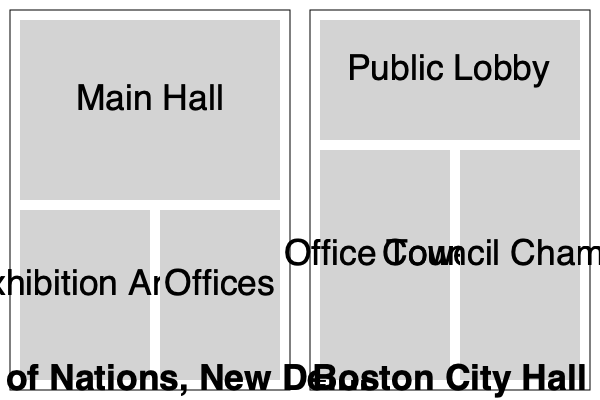Compare and contrast the floor plans of the Hall of Nations in New Delhi and Boston City Hall, focusing on how their spatial arrangements reflect Brutalist principles and their respective functions. How do these designs embody the cultural and political contexts of their locations? To answer this question, we need to analyze the floor plans of both structures step-by-step:

1. Hall of Nations, New Delhi:
   a) Large central space (Main Hall) occupying about half the building's area.
   b) Two smaller spaces below: Exhibition Area and Offices.
   c) Simple, geometric layout with clear divisions.

2. Boston City Hall:
   a) Large Public Lobby at the top.
   b) Two vertical sections below: Office Tower and Council Chamber.
   c) More complex spatial arrangement compared to Hall of Nations.

3. Brutalist principles reflected in both:
   a) Emphasis on raw, exposed structures evident in the simple, geometric forms.
   b) Functionality prioritized over ornamentation.
   c) Clear separation of spaces based on their purposes.

4. Functional aspects:
   a) Hall of Nations: Designed for exhibitions and events, with a large central space and dedicated exhibition area.
   b) Boston City Hall: Designed for governmental functions, with public access areas and separate spaces for offices and legislative activities.

5. Cultural and political contexts:
   a) Hall of Nations: Reflects India's post-independence modernization and desire for international recognition.
   b) Boston City Hall: Embodies American civic architecture and the idea of transparent, accessible government.

6. Similarities:
   a) Both use a modular approach to space division.
   b) Clear hierarchy of spaces evident in both designs.

7. Differences:
   a) Hall of Nations has a more horizontal layout, while Boston City Hall is more vertically oriented.
   b) Hall of Nations emphasizes a large central space, while Boston City Hall prioritizes the separation of public and administrative areas.

The designs of both structures embody Brutalist principles through their emphasis on functionality, exposed structures, and geometric forms. However, they adapt these principles to suit their specific purposes and cultural contexts, resulting in distinct spatial arrangements that reflect their respective functions as an exhibition space and a government building.
Answer: Both embody Brutalist principles through functionality and geometric forms, but differ in layout (horizontal vs. vertical) and space allocation, reflecting their distinct purposes and cultural contexts. 